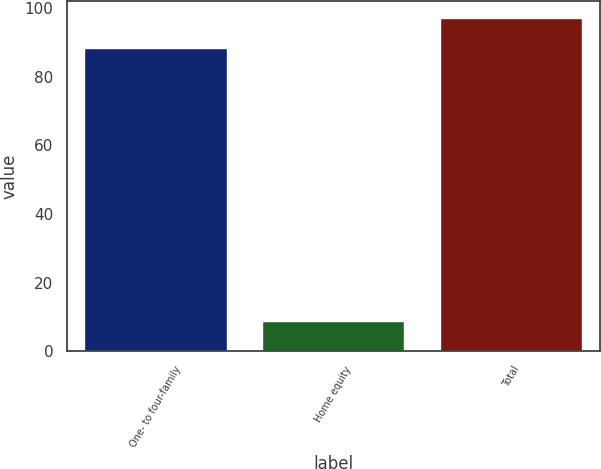Convert chart. <chart><loc_0><loc_0><loc_500><loc_500><bar_chart><fcel>One- to four-family<fcel>Home equity<fcel>Total<nl><fcel>88.3<fcel>8.7<fcel>97.13<nl></chart> 